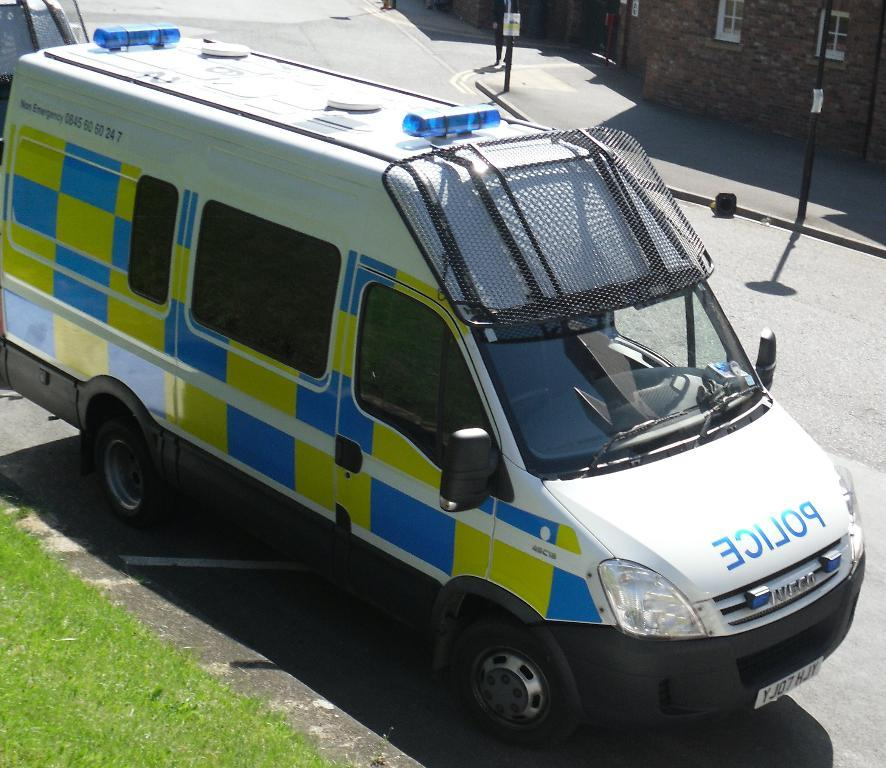What is the main subject of the image? The main subject of the image is a vehicle. What features can be observed on the vehicle? The vehicle has windows and lights. Is there any text or information on the vehicle? Yes, there is something written on the vehicle. What can be seen in the left corner of the image? There is a grass lawn in the left corner of the image. What is present in the right corner of the image? There are poles and a building with windows in the right corner of the image. How does the nail guide the vehicle in the image? There is no nail present in the image, and therefore it cannot guide the vehicle. 